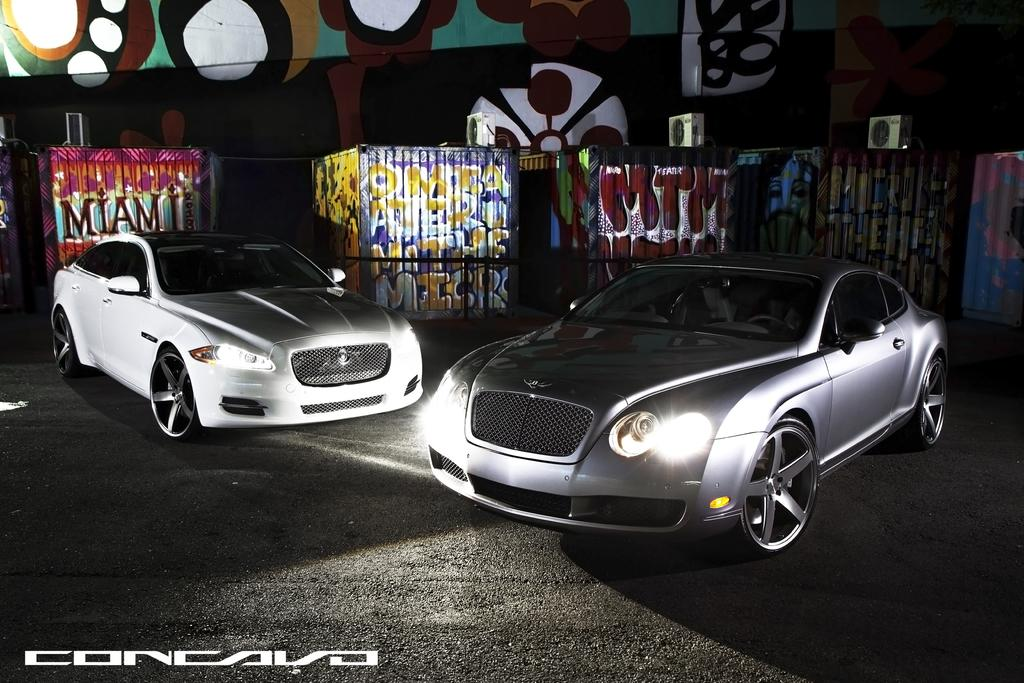How many cars are visible in the image? There are two cars in the image. What can be seen in the background of the image? There is graffiti in the background of the image. Is there any additional information or branding present in the image? Yes, there is a watermark in the image. How would you describe the overall lighting or brightness of the image? The image appears to be slightly dark. What type of coat is hanging on the tray in the image? A: There is no coat or tray present in the image. What is the title of the image? The image does not have a title, as it is a photograph or illustration and not a piece of text or literature. 